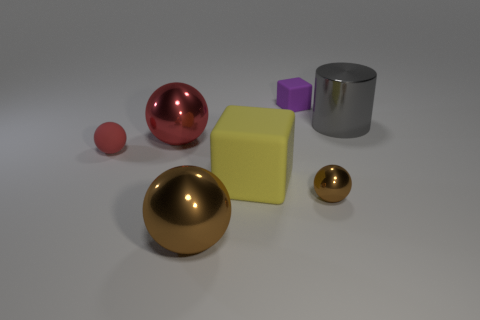There is a big metallic ball that is behind the yellow object that is in front of the large metallic object on the right side of the big yellow cube; what color is it?
Provide a short and direct response. Red. Do the large cylinder and the small matte cube have the same color?
Offer a very short reply. No. How many balls have the same size as the yellow matte object?
Offer a very short reply. 2. Is the number of metallic objects right of the purple thing greater than the number of small red spheres to the left of the small red rubber ball?
Offer a very short reply. Yes. There is a small sphere to the left of the large metallic sphere in front of the small rubber sphere; what color is it?
Provide a short and direct response. Red. Do the small purple cube and the large yellow thing have the same material?
Make the answer very short. Yes. Is there a large yellow matte thing of the same shape as the gray metallic object?
Provide a short and direct response. No. Do the matte block in front of the big cylinder and the large cylinder have the same color?
Keep it short and to the point. No. There is a brown metal object left of the yellow cube; does it have the same size as the brown metal object that is on the right side of the big matte object?
Keep it short and to the point. No. The yellow object that is made of the same material as the purple block is what size?
Your answer should be very brief. Large. 